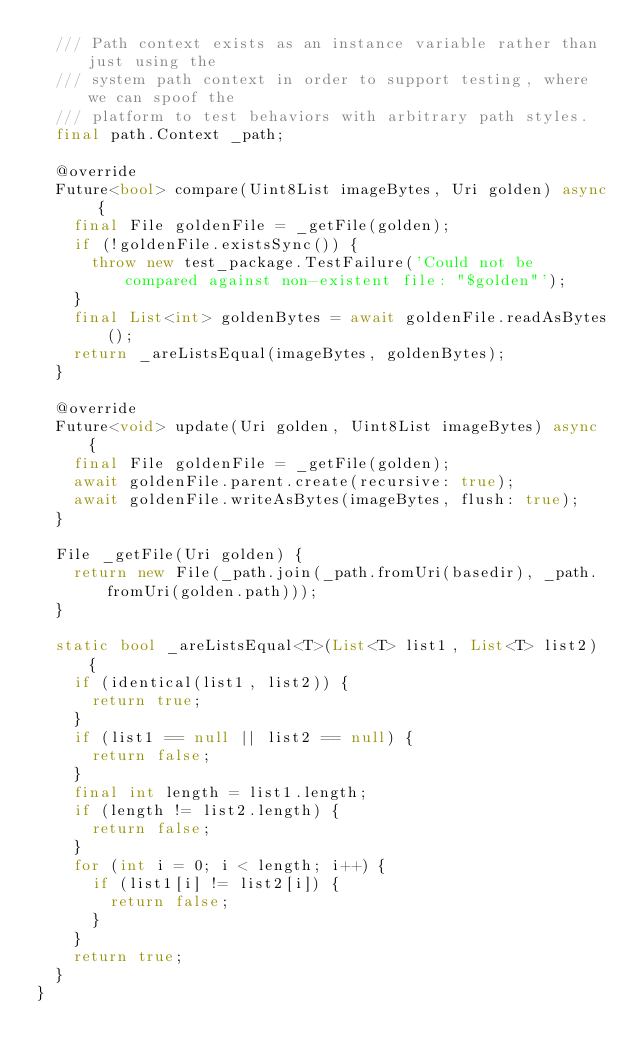<code> <loc_0><loc_0><loc_500><loc_500><_Dart_>  /// Path context exists as an instance variable rather than just using the
  /// system path context in order to support testing, where we can spoof the
  /// platform to test behaviors with arbitrary path styles.
  final path.Context _path;

  @override
  Future<bool> compare(Uint8List imageBytes, Uri golden) async {
    final File goldenFile = _getFile(golden);
    if (!goldenFile.existsSync()) {
      throw new test_package.TestFailure('Could not be compared against non-existent file: "$golden"');
    }
    final List<int> goldenBytes = await goldenFile.readAsBytes();
    return _areListsEqual(imageBytes, goldenBytes);
  }

  @override
  Future<void> update(Uri golden, Uint8List imageBytes) async {
    final File goldenFile = _getFile(golden);
    await goldenFile.parent.create(recursive: true);
    await goldenFile.writeAsBytes(imageBytes, flush: true);
  }

  File _getFile(Uri golden) {
    return new File(_path.join(_path.fromUri(basedir), _path.fromUri(golden.path)));
  }

  static bool _areListsEqual<T>(List<T> list1, List<T> list2) {
    if (identical(list1, list2)) {
      return true;
    }
    if (list1 == null || list2 == null) {
      return false;
    }
    final int length = list1.length;
    if (length != list2.length) {
      return false;
    }
    for (int i = 0; i < length; i++) {
      if (list1[i] != list2[i]) {
        return false;
      }
    }
    return true;
  }
}
</code> 